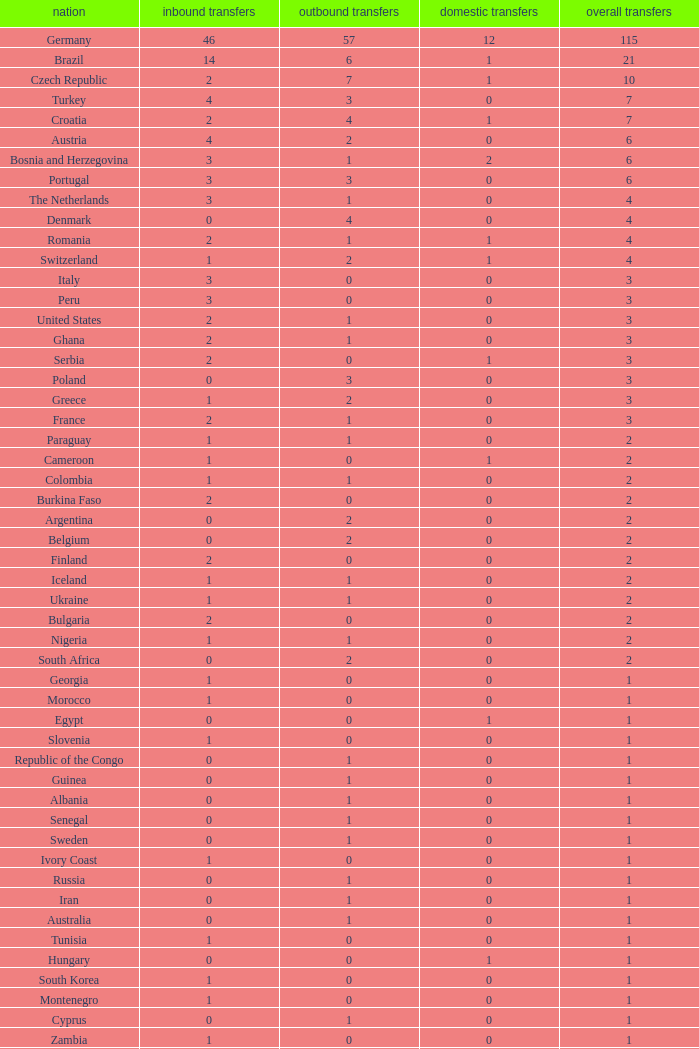What are the transfers in for Hungary? 0.0. 